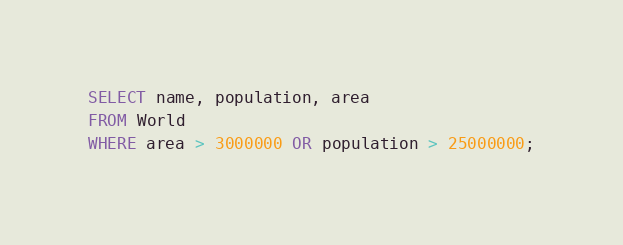<code> <loc_0><loc_0><loc_500><loc_500><_SQL_>SELECT name, population, area
FROM World
WHERE area > 3000000 OR population > 25000000;
</code> 